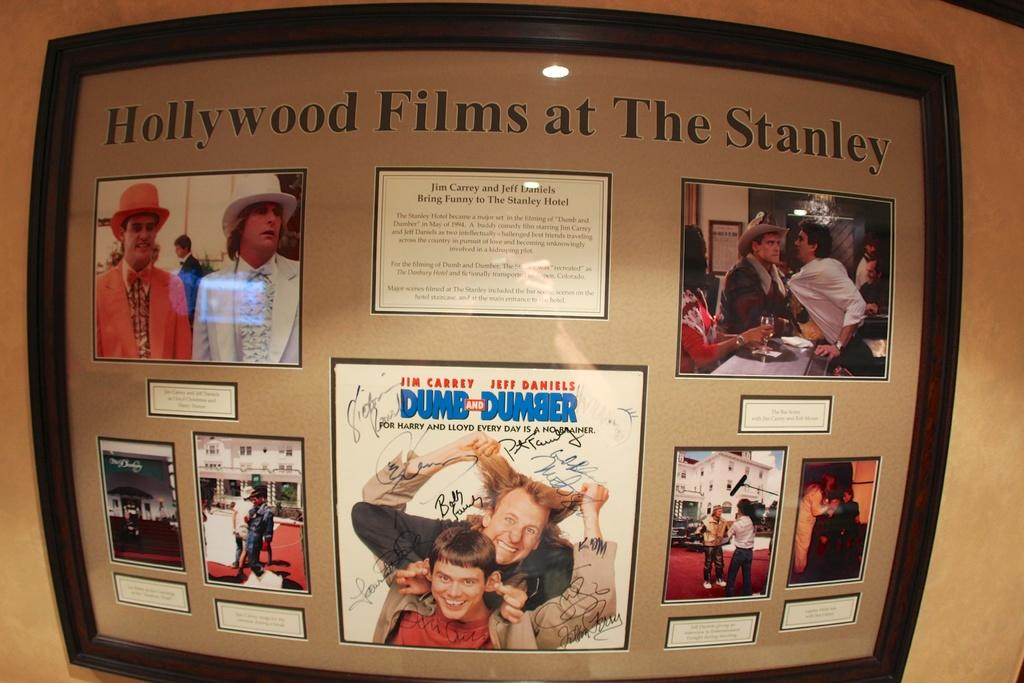<image>
Provide a brief description of the given image. A Hollywood Films collage framed on a wall. 